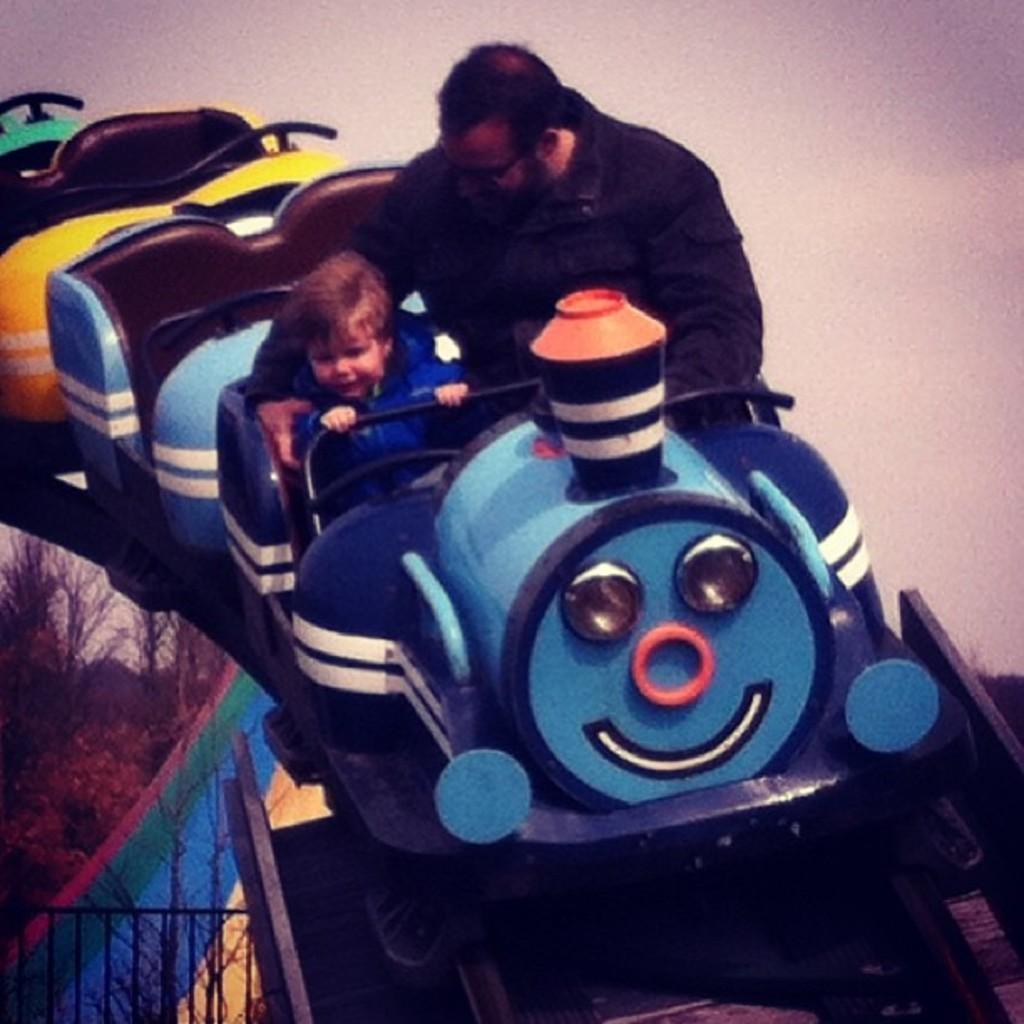Could you give a brief overview of what you see in this image? In this image we can see two persons sitting on a ride. One person is wearing spectacles and a black jacket. In the background, we can see a metal barricade, group of trees and the sky. 